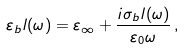<formula> <loc_0><loc_0><loc_500><loc_500>\varepsilon _ { b } l ( \omega ) = \varepsilon _ { \infty } + \frac { i \sigma _ { b } l ( \omega ) } { \varepsilon _ { 0 } \omega } \, ,</formula> 